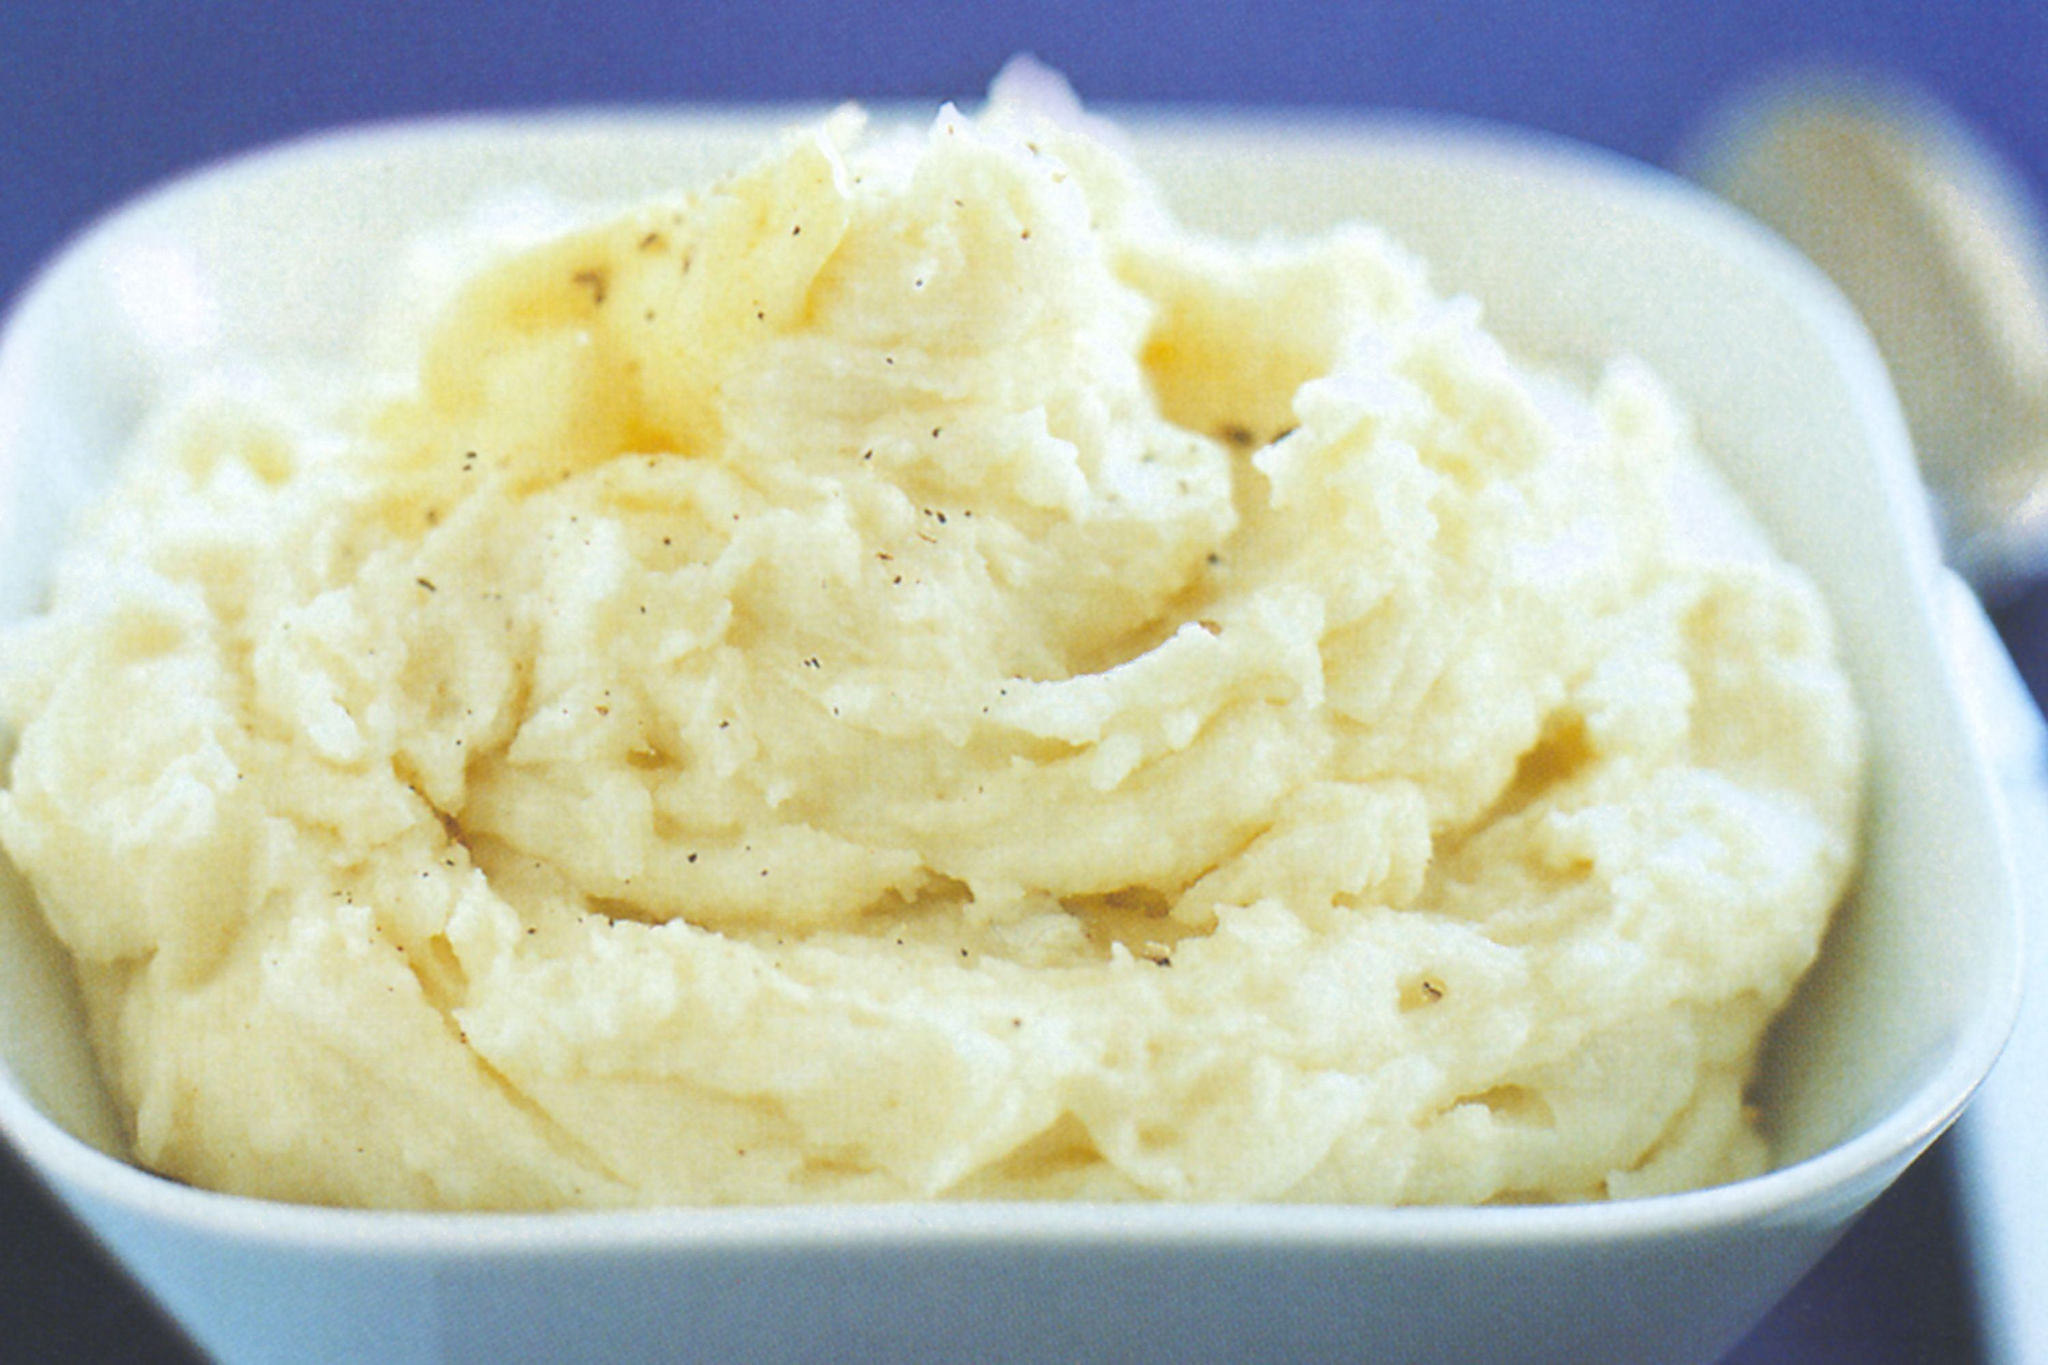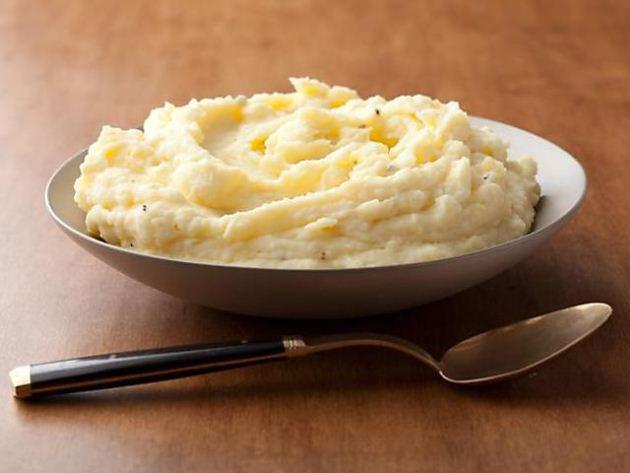The first image is the image on the left, the second image is the image on the right. Assess this claim about the two images: "One of the bowls is green". Correct or not? Answer yes or no. No. 